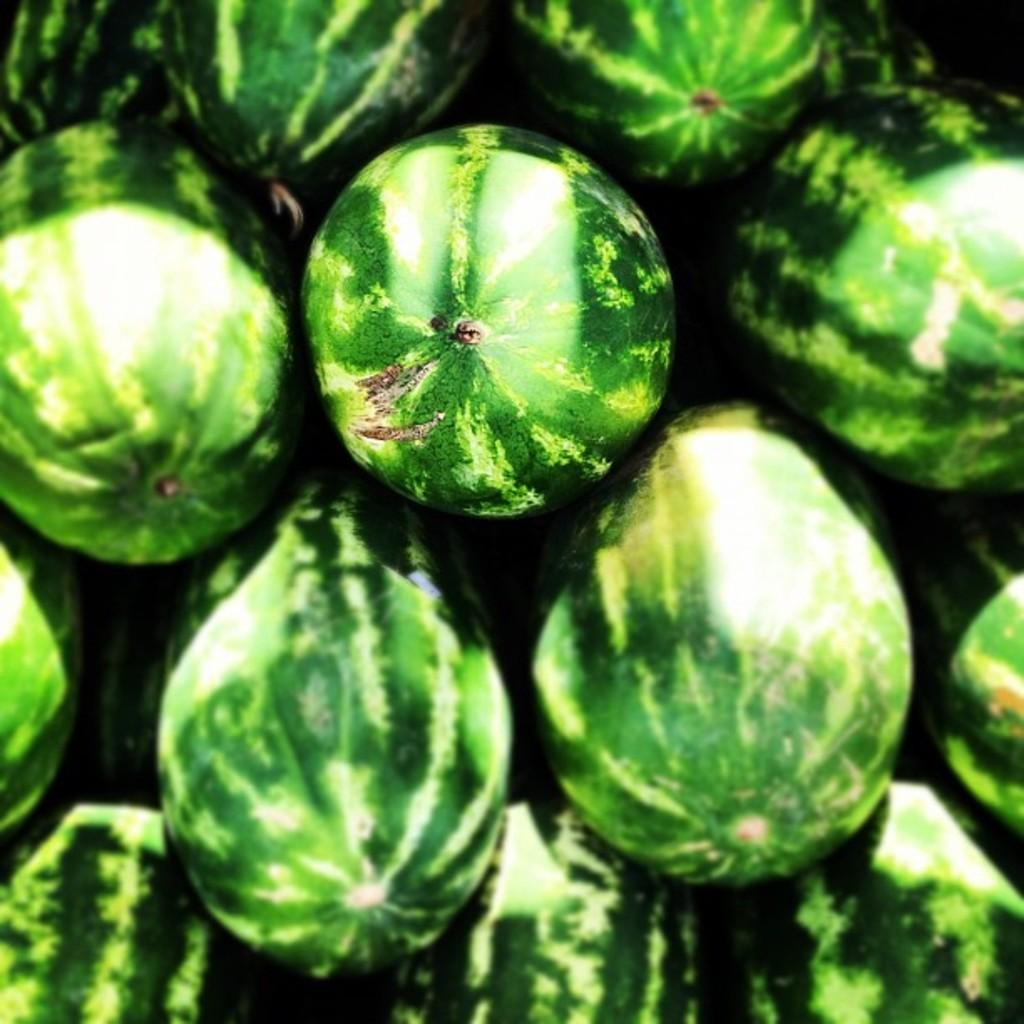What type of fruit is present in the image? There are green watermelons in the image. What advice does the father give about the pest problem in the image? There is no father or pest problem present in the image; it only features green watermelons. 